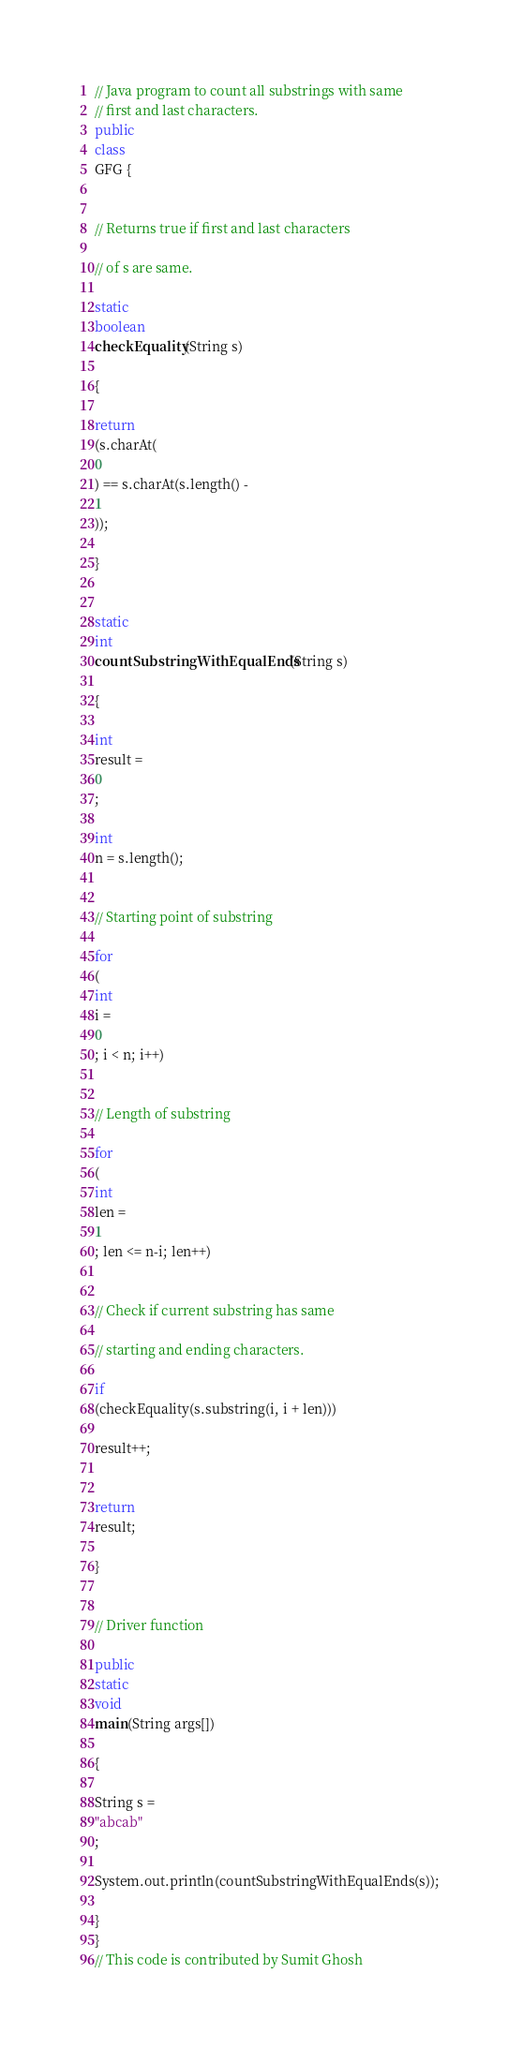<code> <loc_0><loc_0><loc_500><loc_500><_Java_>
// Java program to count all substrings with same 
// first and last characters. 
public
class
GFG { 


// Returns true if first and last characters 

// of s are same. 

static
boolean
checkEquality(String s) 

{ 

return
(s.charAt(
0
) == s.charAt(s.length() - 
1
)); 

} 


static
int
countSubstringWithEqualEnds(String s) 

{ 

int
result = 
0
; 

int
n = s.length(); 


// Starting point of substring 

for
(
int
i = 
0
; i < n; i++) 


// Length of substring 

for
(
int
len = 
1
; len <= n-i; len++) 


// Check if current substring has same 

// starting and ending characters. 

if
(checkEquality(s.substring(i, i + len))) 

result++; 


return
result; 

} 


// Driver function 

public
static
void
main(String args[]) 

{ 

String s = 
"abcab"
; 

System.out.println(countSubstringWithEqualEnds(s)); 

} 
} 
// This code is contributed by Sumit Ghosh </code> 